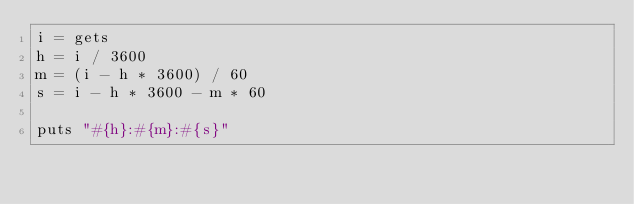Convert code to text. <code><loc_0><loc_0><loc_500><loc_500><_Ruby_>i = gets
h = i / 3600
m = (i - h * 3600) / 60 
s = i - h * 3600 - m * 60

puts "#{h}:#{m}:#{s}"</code> 